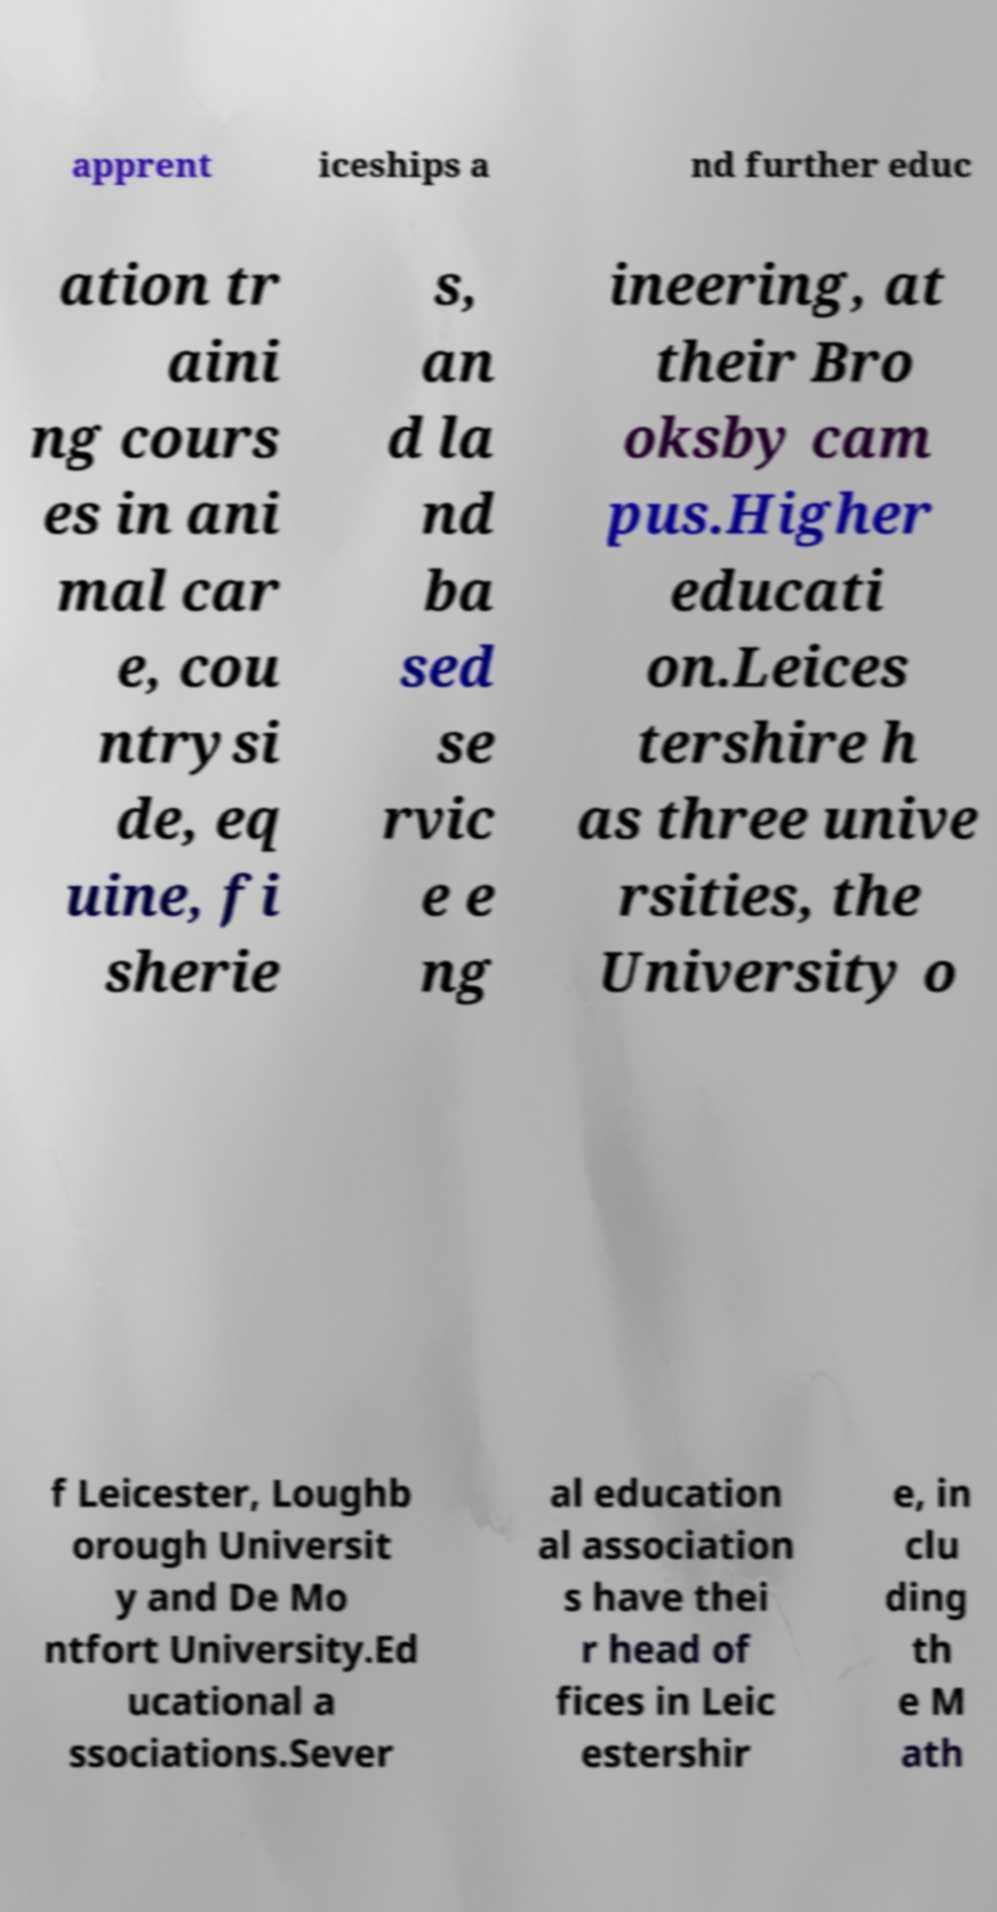Please read and relay the text visible in this image. What does it say? apprent iceships a nd further educ ation tr aini ng cours es in ani mal car e, cou ntrysi de, eq uine, fi sherie s, an d la nd ba sed se rvic e e ng ineering, at their Bro oksby cam pus.Higher educati on.Leices tershire h as three unive rsities, the University o f Leicester, Loughb orough Universit y and De Mo ntfort University.Ed ucational a ssociations.Sever al education al association s have thei r head of fices in Leic estershir e, in clu ding th e M ath 